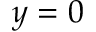Convert formula to latex. <formula><loc_0><loc_0><loc_500><loc_500>y = 0</formula> 